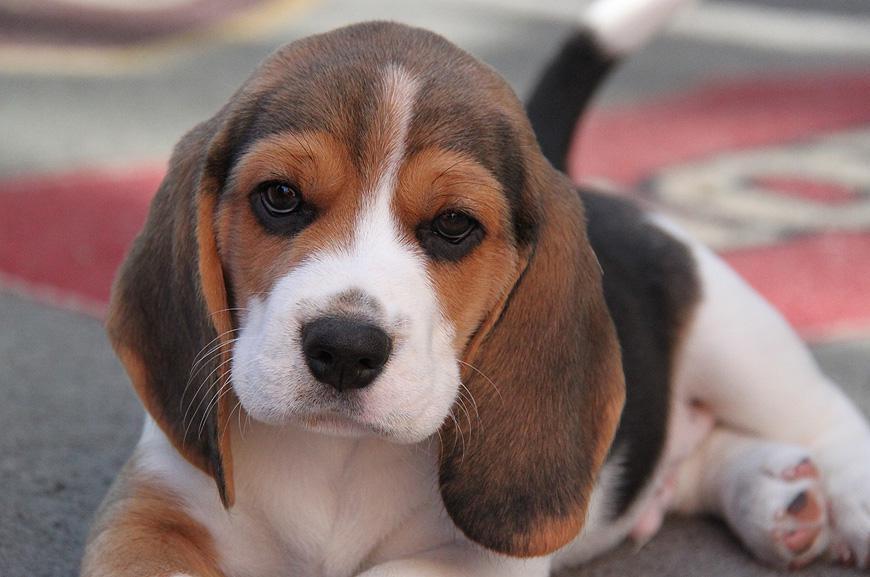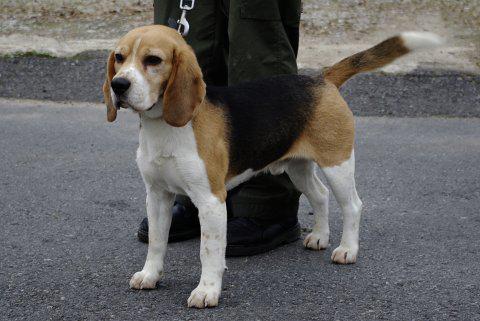The first image is the image on the left, the second image is the image on the right. Assess this claim about the two images: "There are exactly two dogs in total.". Correct or not? Answer yes or no. Yes. The first image is the image on the left, the second image is the image on the right. Assess this claim about the two images: "Each image contains at least one beagle standing on all fours outdoors on the ground.". Correct or not? Answer yes or no. No. 